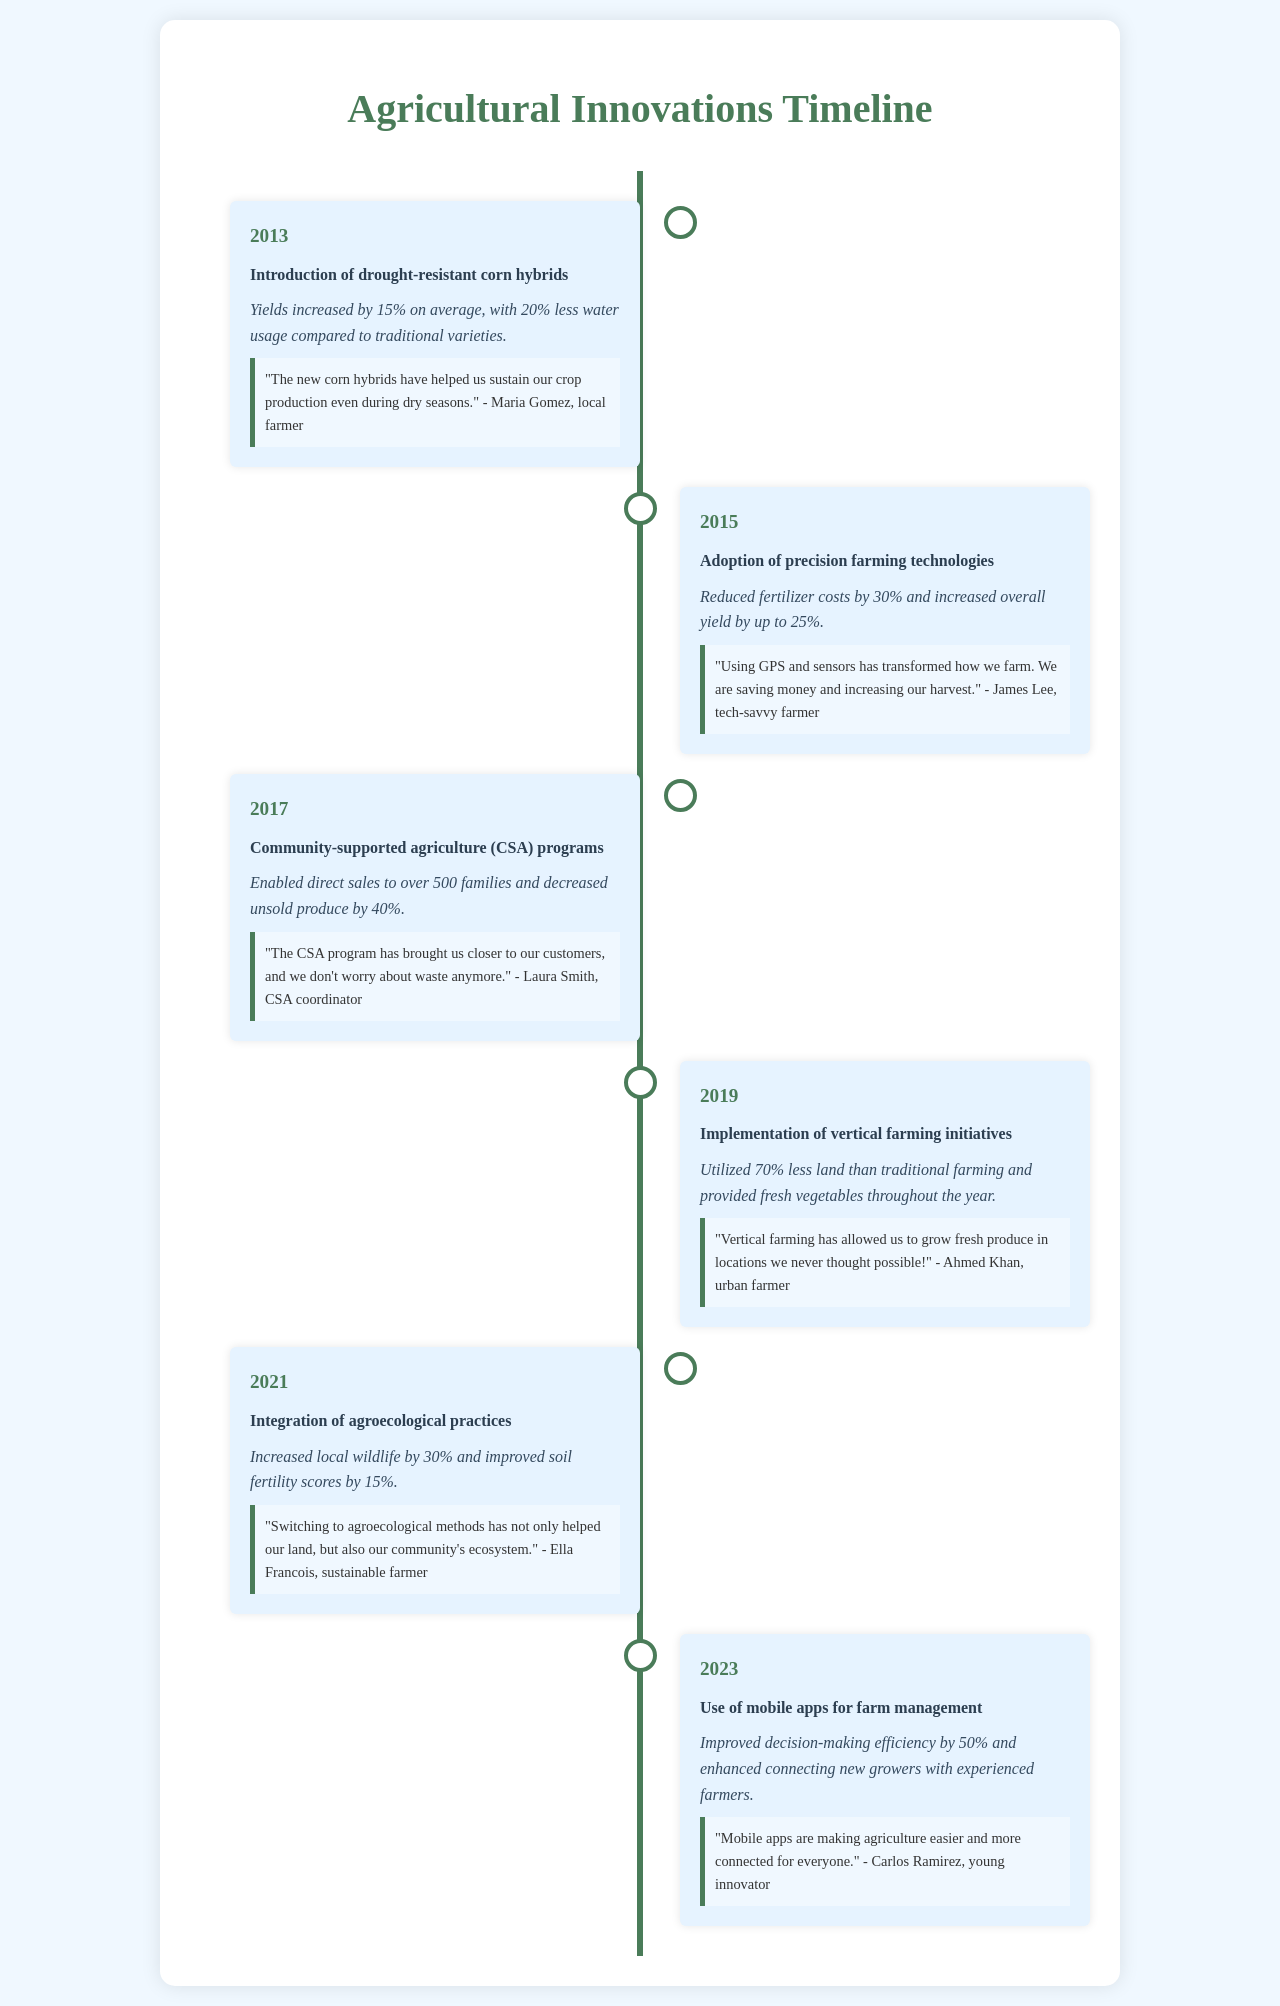what agricultural innovation was introduced in 2013? The document states that in 2013, drought-resistant corn hybrids were introduced as an agricultural innovation.
Answer: drought-resistant corn hybrids what was the impact of the precision farming technologies adopted in 2015? According to the document, the impact was reduced fertilizer costs by 30% and increased overall yield by up to 25%.
Answer: Reduced fertilizer costs by 30% how many families benefited from the community-supported agriculture programs launched in 2017? The document indicates that over 500 families benefited from the CSA programs initiated in 2017.
Answer: over 500 families what year was vertical farming implemented in the community? The implementation of vertical farming initiatives occurred in 2019, as stated in the document.
Answer: 2019 which agricultural practice increased local wildlife by 30%? The document mentions that integration of agroecological practices led to an increase in local wildlife by 30%.
Answer: agroecological practices which testimonial highlights the role of technology in farming in 2023? The document's testimonial from Carlos Ramirez discusses how mobile apps are making agriculture easier and more connected for everyone in 2023.
Answer: mobile apps what was the main focus of the innovation introduced in 2021? The innovation introduced in 2021 focused on the integration of agroecological practices, as detailed in the document.
Answer: agroecological practices what is a significant advantage of the mobile apps for farm management mentioned in 2023? The document specifies that mobile apps improved decision-making efficiency by 50%.
Answer: Improved decision-making efficiency by 50% how did the drought-resistant corn hybrids help farmers? According to the testimonial, the drought-resistant corn hybrids helped sustain crop production during dry seasons.
Answer: sustain crop production during dry seasons 